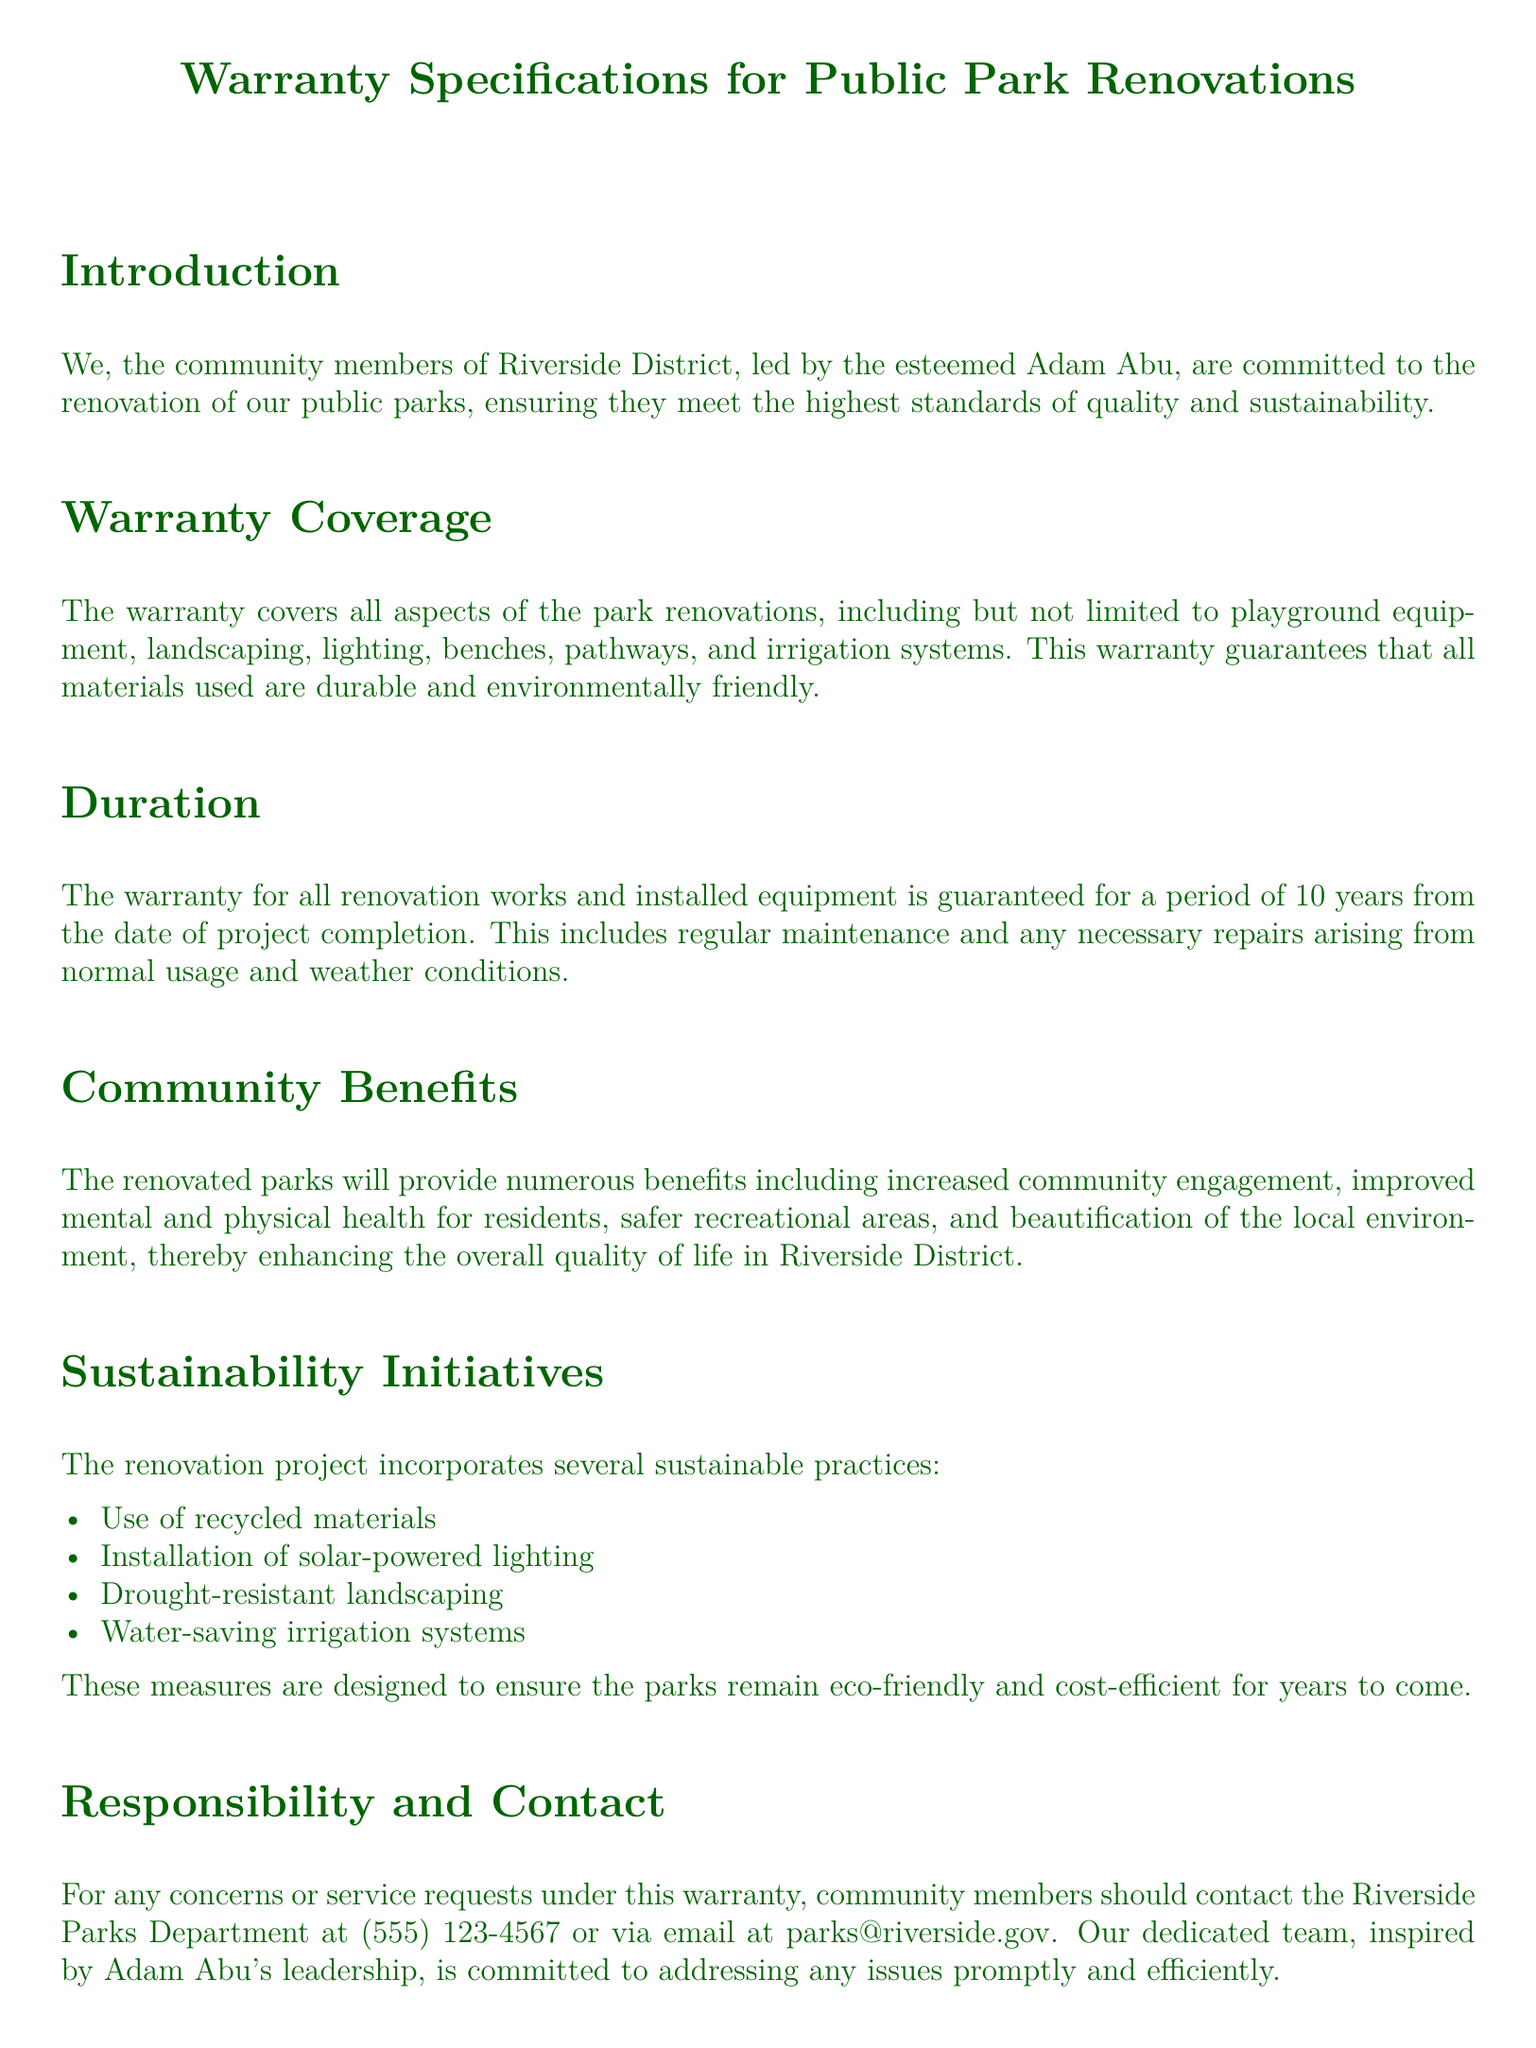What is the duration of the warranty? The duration of the warranty is stated as 10 years from the date of project completion.
Answer: 10 years What items are covered under the warranty? The warranty specifies the coverage of playground equipment, landscaping, lighting, benches, pathways, and irrigation systems.
Answer: Playground equipment, landscaping, lighting, benches, pathways, irrigation systems What type of lighting is installed in the park? The document mentions the installation of solar-powered lighting as part of sustainability initiatives.
Answer: Solar-powered lighting What is one community benefit mentioned in the document? The warranty highlights several community benefits, one of which is improved mental and physical health for residents.
Answer: Improved mental and physical health Who should community members contact for warranty concerns? The document provides a contact for warranty concerns as the Riverside Parks Department.
Answer: Riverside Parks Department What sustainable practice involves using less water? The warranty details a sustainability initiative concerning water, which is the installation of water-saving irrigation systems.
Answer: Water-saving irrigation systems What leadership role does Adam Abu hold? The document refers to Adam Abu as the Riverside District Leader.
Answer: Riverside District Leader What is the primary commitment signified by the warranty? The warranty underscores a commitment to maintaining public parks as safe, inclusive, and environmentally responsible spaces.
Answer: Maintaining public parks as safe and inclusive spaces 